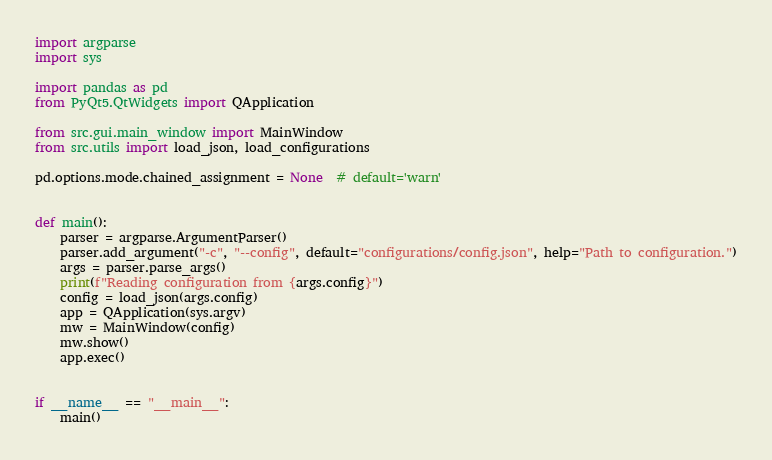<code> <loc_0><loc_0><loc_500><loc_500><_Python_>import argparse
import sys

import pandas as pd
from PyQt5.QtWidgets import QApplication

from src.gui.main_window import MainWindow
from src.utils import load_json, load_configurations

pd.options.mode.chained_assignment = None  # default='warn'


def main():
    parser = argparse.ArgumentParser()
    parser.add_argument("-c", "--config", default="configurations/config.json", help="Path to configuration.")
    args = parser.parse_args()
    print(f"Reading configuration from {args.config}")
    config = load_json(args.config)
    app = QApplication(sys.argv)
    mw = MainWindow(config)
    mw.show()
    app.exec()


if __name__ == "__main__":
    main()
</code> 